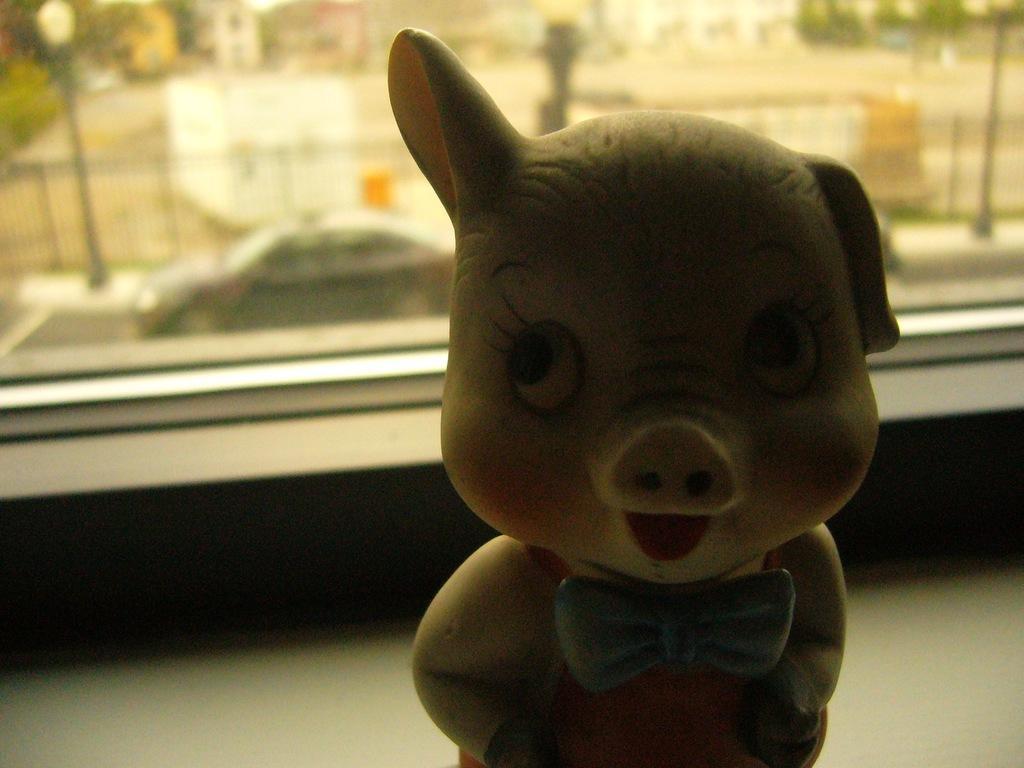Describe this image in one or two sentences. In this image there is a toy, behind the toy there is a glass window through which we can see there is a vehicle on the road, trees, railing, poles and buildings. 